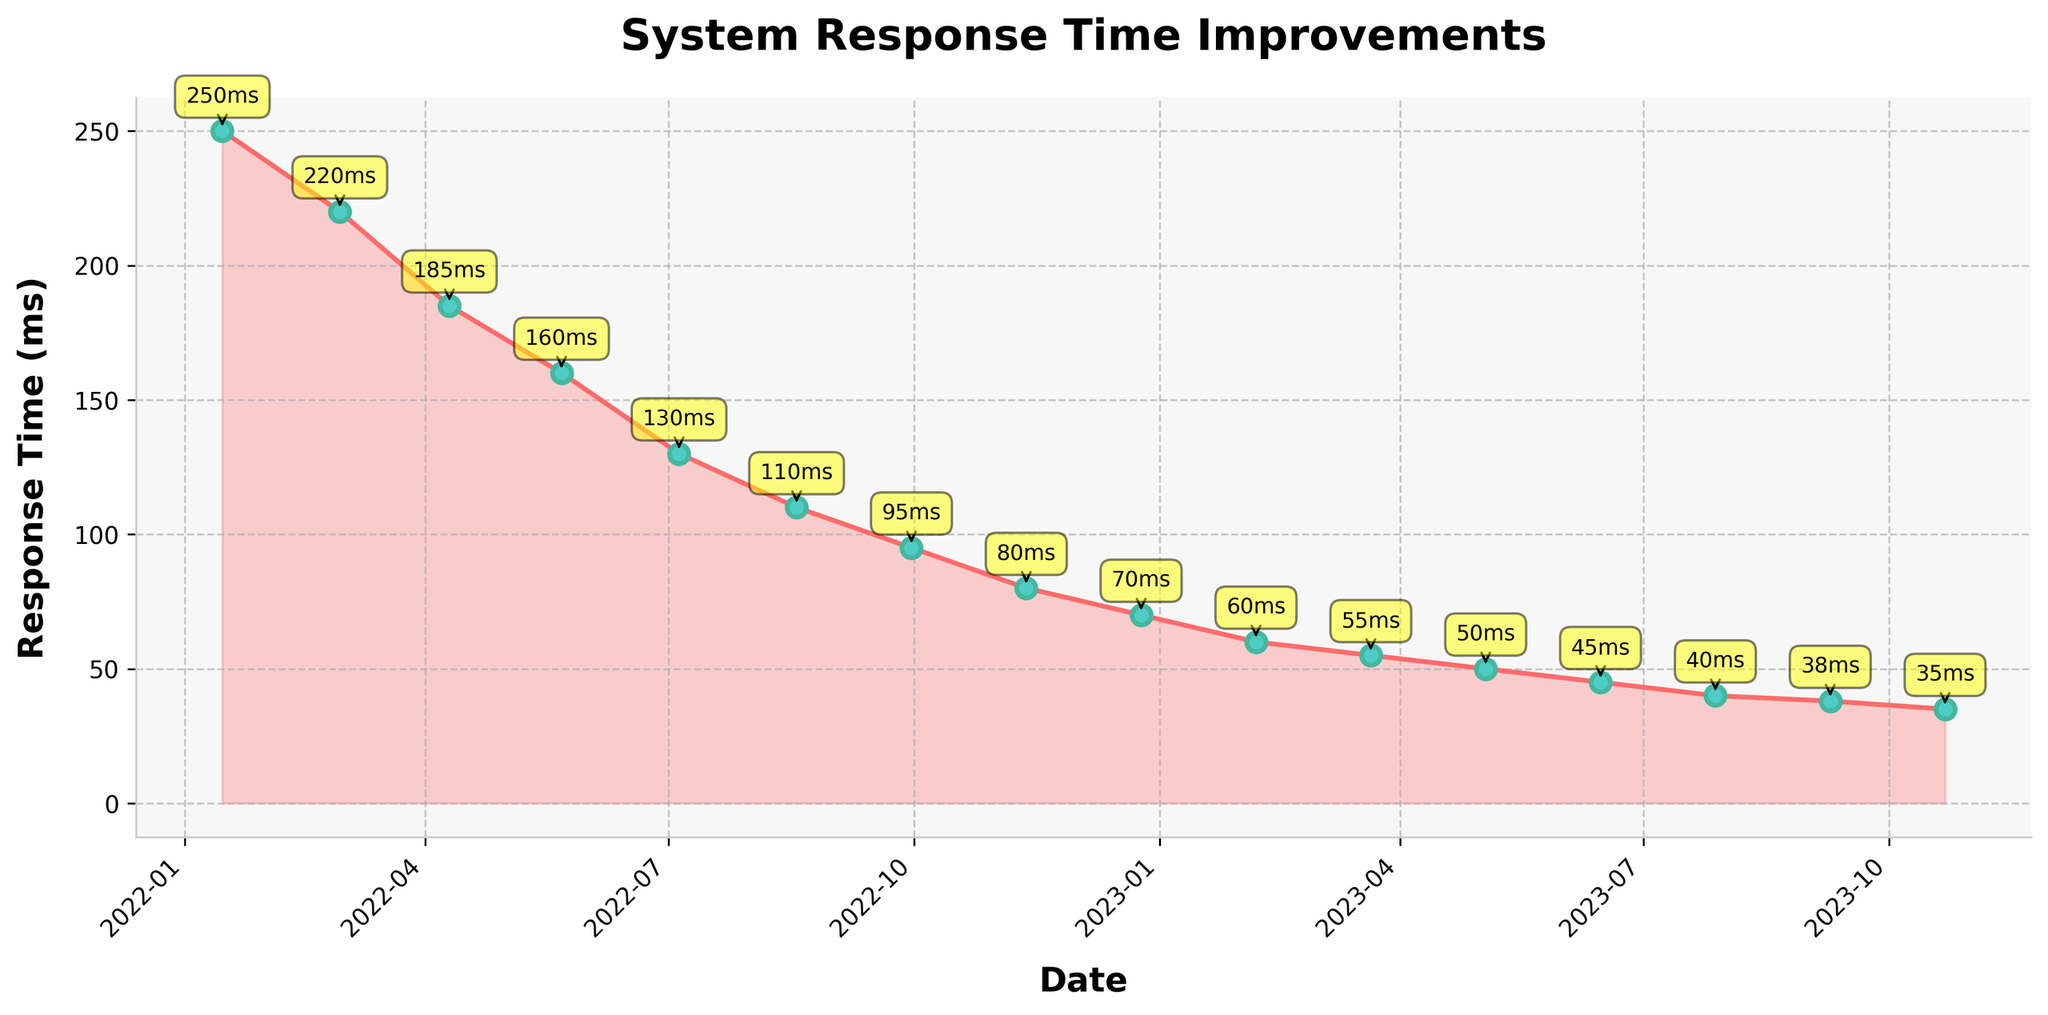What is the lowest response time recorded in the figure? Identify and pick the smallest value from the y-axis response times.
Answer: 35 ms Which month showed the most significant improvement in response time? Compare the month-to-month differences in response times. The biggest drop was from June to July in 2023 (45 ms to 40 ms, a difference of 5 ms)
Answer: July 2023 Is there any month where the response time did not improve from the previous data point? Observe the figure and check if any data point is higher than the previous one. No such month exists.
Answer: No During which months in 2023 did the response time stay the same? Look for flat segments in 2023. The response time remained constant at 50 ms from May 2023 to June 2023.
Answer: May to June 2023 How many months did it take to reach below 50 ms response time from the start of the timeframe? Count the number of months from January 2022 until the first time the response time dropped below 50 ms (June 2023).
Answer: 17 months Which color is predominantly used for the markers in the chart? Identify the color used for the markers by visually inspecting them.
Answer: Turquoise Visualize the trend over the six-month window with the most rapid drop in response time. What can you conclude? Identify the steepest slope in any six-month window. From July 2022 (130 ms) to January 2023 (70 ms), a drop of 60 ms.
Answer: Rapid improvement occurred showing effective optimization steps 